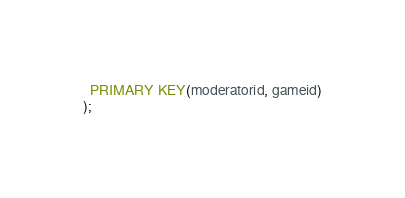<code> <loc_0><loc_0><loc_500><loc_500><_SQL_>  PRIMARY KEY(moderatorid, gameid)
);
</code> 